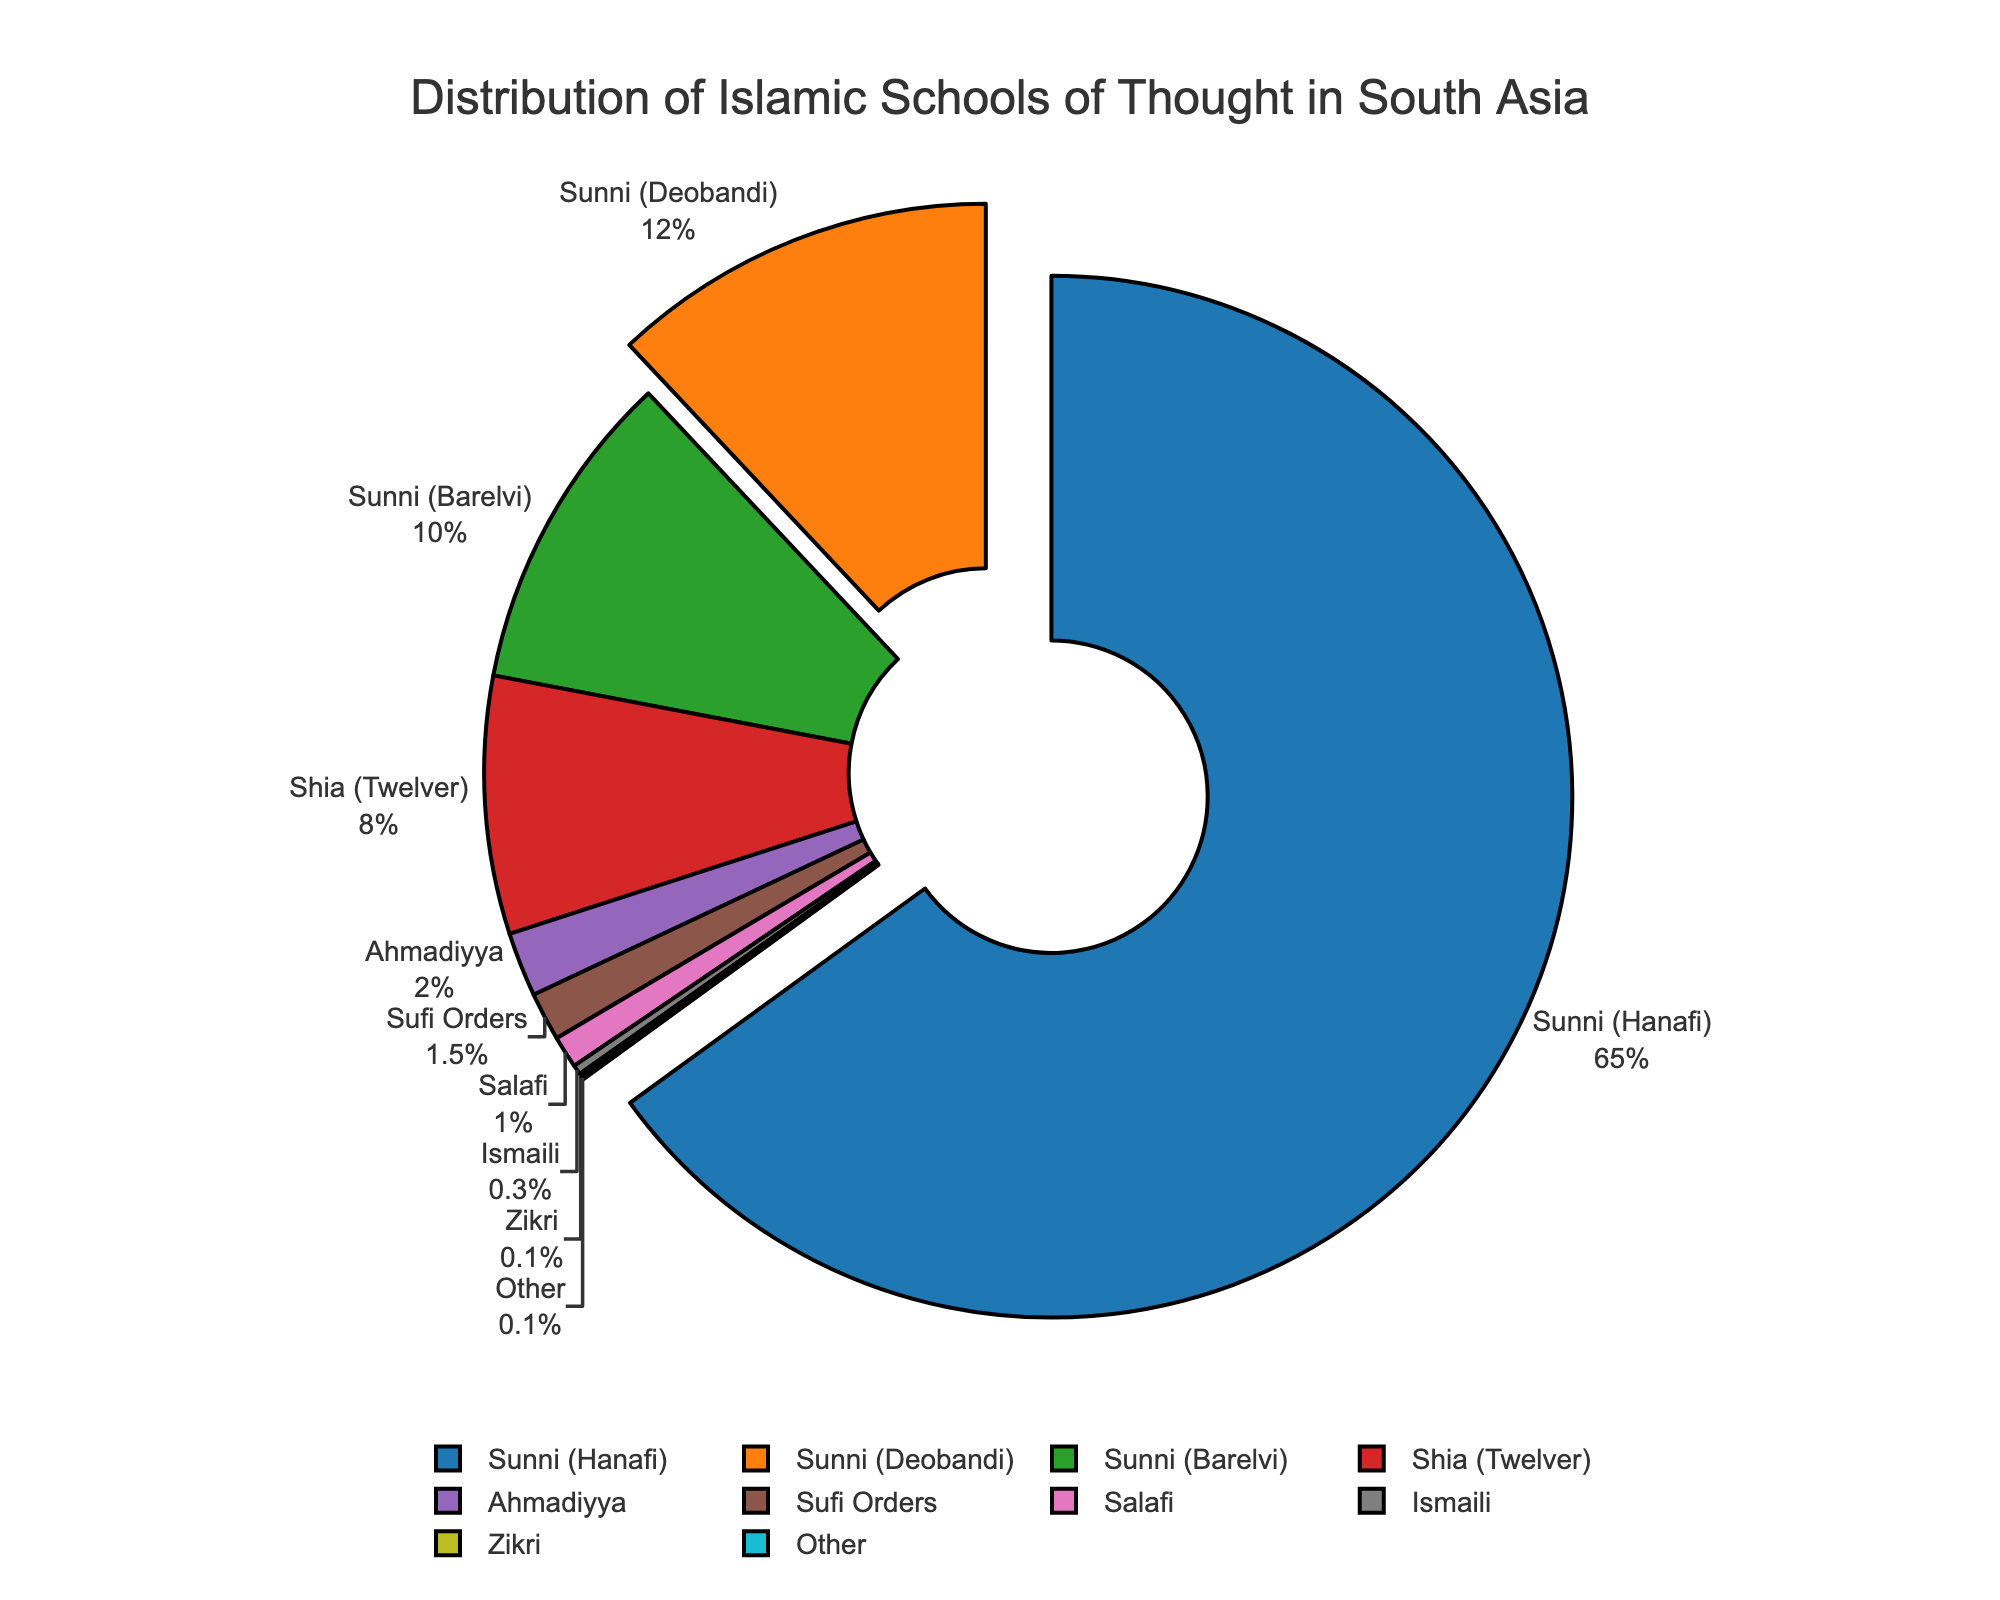What is the total percentage of Sunni Muslims (including Hanafi, Deobandi, and Barelvi) in South Asia? To find the total percentage of Sunni Muslims, we need to sum the percentages of Sunni (Hanafi), Sunni (Deobandi), and Sunni (Barelvi). The total percentage is 65% + 12% + 10%.
Answer: 87% Which Islamic school of thought has the smallest representation in South Asia? By looking at the pie chart, we can identify the smallest segment, which belongs to the school of thought with the 0.1% share.
Answer: Zikri and Other How does the percentage of Ahmadiyya compare to that of Shia (Twelver)? The percentage of Shia (Twelver) is 8%, while Ahmadiyya represents 2%. Therefore, Shia (Twelver) is 6% more than Ahmadiyya.
Answer: Shia (Twelver) is 6% more than Ahmadiyya What fraction of the total is formed by Sufi Orders and Salafi combined? To find this, we sum the percentages of Sufi Orders (1.5%) and Salafi (1%), which gives us a total of 2.5%.
Answer: 2.5% Is the percentage of Sunni (Deobandi) greater than the sum of Ahmadiyya, Sufi Orders, and Salafi? We need to compare Sunni (Deobandi)'s 12% to the combined 2% (Ahmadiyya) + 1.5% (Sufi Orders) + 1% (Salafi). The sum of Ahmadiyya, Sufi Orders, and Salafi is 4.5%. Therefore, Sunni (Deobandi) has a higher percentage (12% > 4.5%).
Answer: Yes What percentage do Ismaili and Zikri form together? Adding up the percentages of Ismaili (0.3%) and Zikri (0.1%) gives us 0.4%.
Answer: 0.4% Between Sunni (Barelvi) and Shia (Twelver), which school of thought has a lower representation? By looking at their respective percentages, Sunni (Barelvi) has 10% and Shia (Twelver) has 8%. Thus, Shia (Twelver) has a lower representation.
Answer: Shia (Twelver) What is the visual distinction used to highlight schools of thought with more than 10% representation? The visual distinction for segments with more than 10% representation is that they are pulled out slightly from the pie chart. This can be observed for Sunni (Hanafi) and Sunni (Deobandi).
Answer: Pulled-out segments 